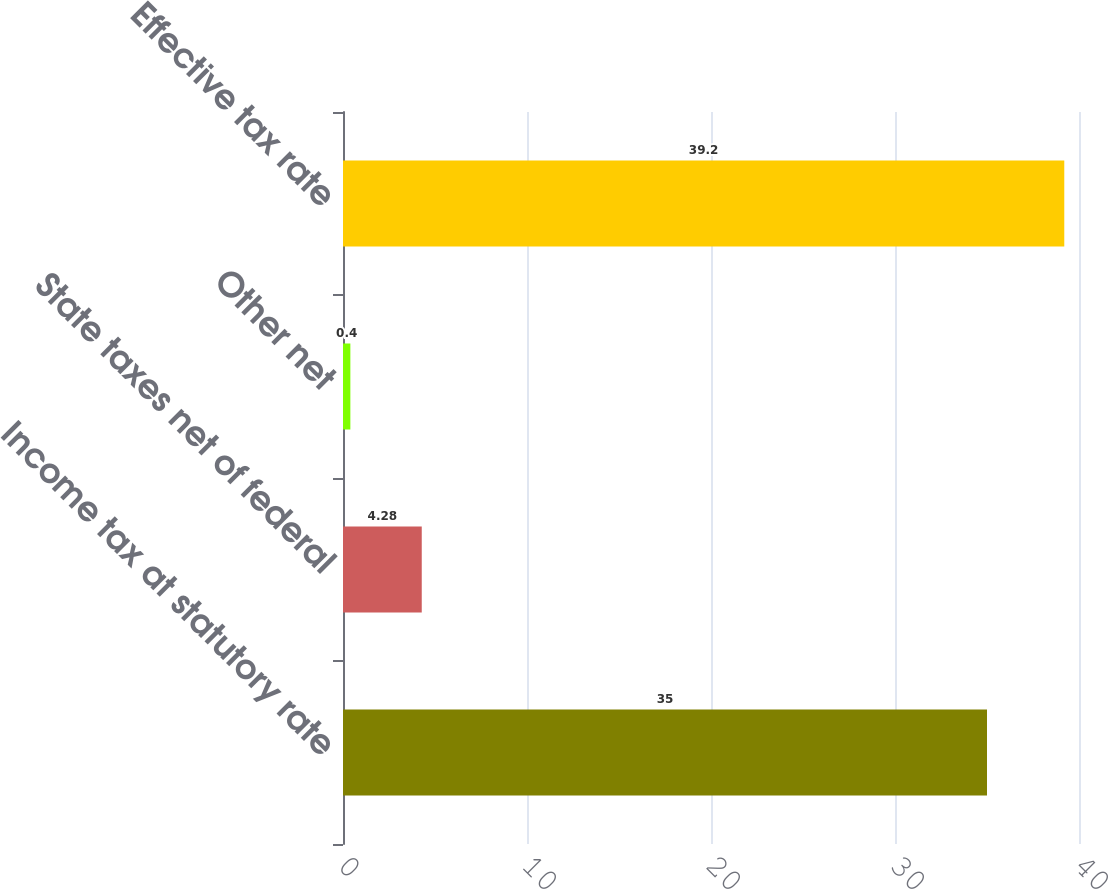<chart> <loc_0><loc_0><loc_500><loc_500><bar_chart><fcel>Income tax at statutory rate<fcel>State taxes net of federal<fcel>Other net<fcel>Effective tax rate<nl><fcel>35<fcel>4.28<fcel>0.4<fcel>39.2<nl></chart> 